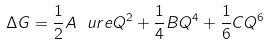<formula> <loc_0><loc_0><loc_500><loc_500>\Delta G = \frac { 1 } { 2 } A \ u r e Q ^ { 2 } + \frac { 1 } { 4 } B Q ^ { 4 } + \frac { 1 } { 6 } C Q ^ { 6 }</formula> 